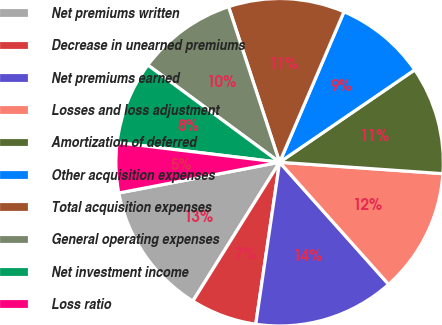Convert chart. <chart><loc_0><loc_0><loc_500><loc_500><pie_chart><fcel>Net premiums written<fcel>Decrease in unearned premiums<fcel>Net premiums earned<fcel>Losses and loss adjustment<fcel>Amortization of deferred<fcel>Other acquisition expenses<fcel>Total acquisition expenses<fcel>General operating expenses<fcel>Net investment income<fcel>Loss ratio<nl><fcel>13.11%<fcel>6.56%<fcel>13.93%<fcel>12.29%<fcel>10.66%<fcel>9.02%<fcel>11.48%<fcel>9.84%<fcel>8.2%<fcel>4.92%<nl></chart> 